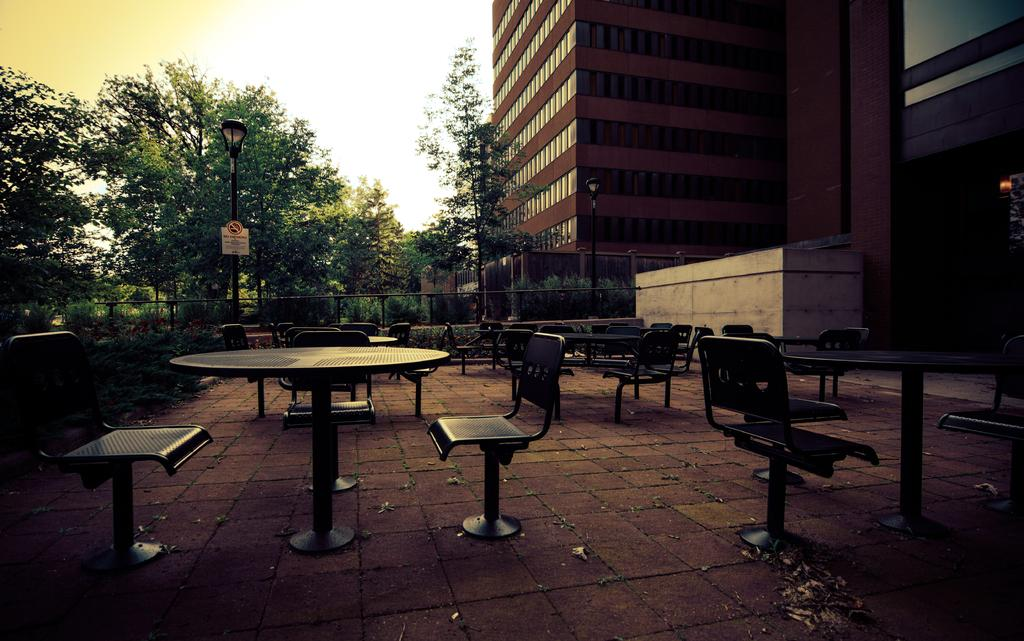What type of structure can be seen in the background of the image? There is a big building in the background of the image. What type of natural elements are present in the image? There are many trees in the image. What type of furniture can be seen in the image? There are many chairs in the image. What type of shirt is hanging on the tree in the image? There is no shirt hanging on a tree in the image; it only features a big building, trees, and chairs. How many stitches are visible on the chairs in the image? The chairs in the image do not have visible stitches, as they are not described in the provided facts. 